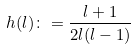<formula> <loc_0><loc_0><loc_500><loc_500>h ( l ) \colon = \frac { l + 1 } { 2 l ( l - 1 ) }</formula> 